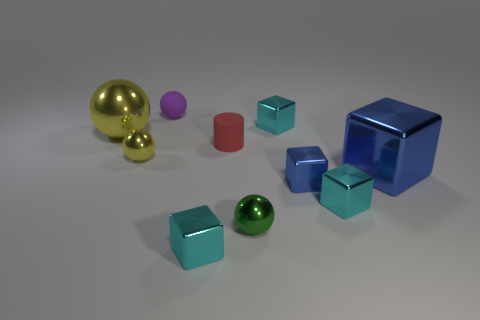What number of things are small purple objects or tiny green balls?
Offer a very short reply. 2. There is a large metallic object behind the matte cylinder; is it the same shape as the tiny green metal thing?
Offer a very short reply. Yes. The shiny cube behind the large sphere behind the red cylinder is what color?
Your answer should be compact. Cyan. Is the number of small gray metal blocks less than the number of small yellow things?
Offer a terse response. Yes. Is there another small cylinder made of the same material as the tiny cylinder?
Offer a terse response. No. There is a small purple object; is its shape the same as the big shiny thing that is on the left side of the large blue metal thing?
Your answer should be compact. Yes. Are there any small yellow spheres on the right side of the red cylinder?
Give a very brief answer. No. What number of large purple things are the same shape as the green thing?
Offer a very short reply. 0. Is the material of the tiny purple ball the same as the tiny sphere left of the small purple rubber object?
Give a very brief answer. No. What number of big blue matte spheres are there?
Make the answer very short. 0. 